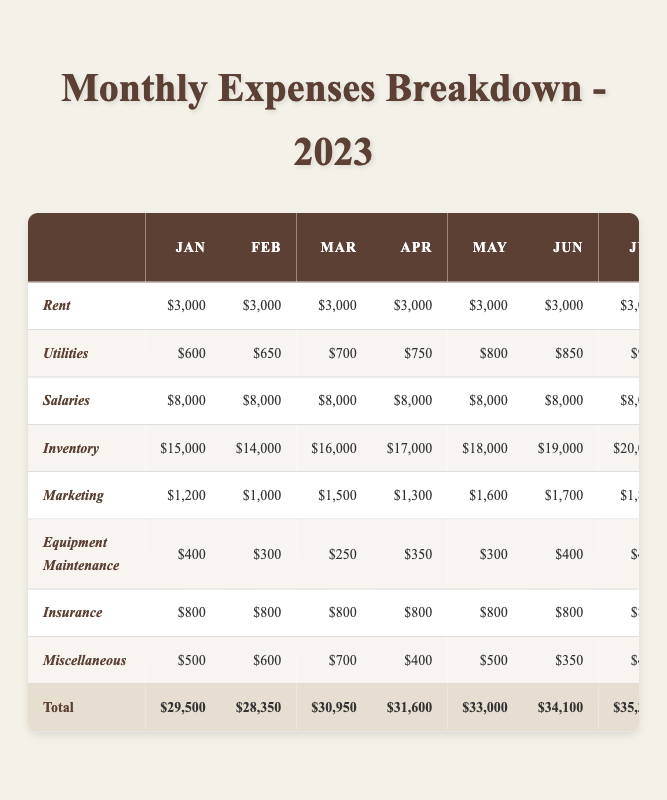What is the total amount spent on Rent in 2023? The table shows that Rent is consistently $3,000 for each month. To find the total, multiply $3,000 by 12 months: $3,000 * 12 = $36,000.
Answer: $36,000 What was the highest month for Marketing expenses? By examining the Marketing expenses for each month, August has the highest amount at $2,000.
Answer: August What are the total expenses for June? To get the total for June, sum up all the expenses listed for that month: $3,000 (Rent) + $850 (Utilities) + $8,000 (Salaries) + $19,000 (Inventory) + $1,700 (Marketing) + $400 (Equipment Maintenance) + $800 (Insurance) + $350 (Miscellaneous) = $34,100.
Answer: $34,100 How much more was spent on Inventory in December compared to January? In December, the Inventory expense is $20,000, and in January, it is $15,000. Subtract January's Inventory from December's: $20,000 - $15,000 = $5,000.
Answer: $5,000 Did the total expenses increase or decrease from January to December? The total expenses for January are $29,500, and for December are $35,500. Since $35,500 is greater than $29,500, it indicates an increase.
Answer: Increase What is the average Utility expense for the year? The monthly Utility expenses are: $600, $650, $700, $750, $800, $850, $900, $950, $800, $750, $700, $600. Adding these gives a total of $9,050. There are 12 months, so $9,050 / 12 = approximately $754.17.
Answer: Approximately $754.17 Which month had the lowest Miscellaneous expenses? Reviewing the Miscellaneous expenses, April had the lowest amount at $400.
Answer: April What is the difference in total salaries between the first half and the second half of the year? The total salaries for each month is $8,000. For the first half (January to June), it's $8,000 * 6 = $48,000. For the second half (July to December), it's also $8,000 * 6 = $48,000. Therefore, the difference is $48,000 - $48,000 = $0.
Answer: $0 How much did Insurance cost over the entire year? The Insurance expense is constant at $800 each month. Therefore, for 12 months, it's $800 * 12 = $9,600.
Answer: $9,600 Which expense category had the greatest total in 2023? By reviewing the totals from each category, Inventory has the greatest total at $208,000.
Answer: Inventory 